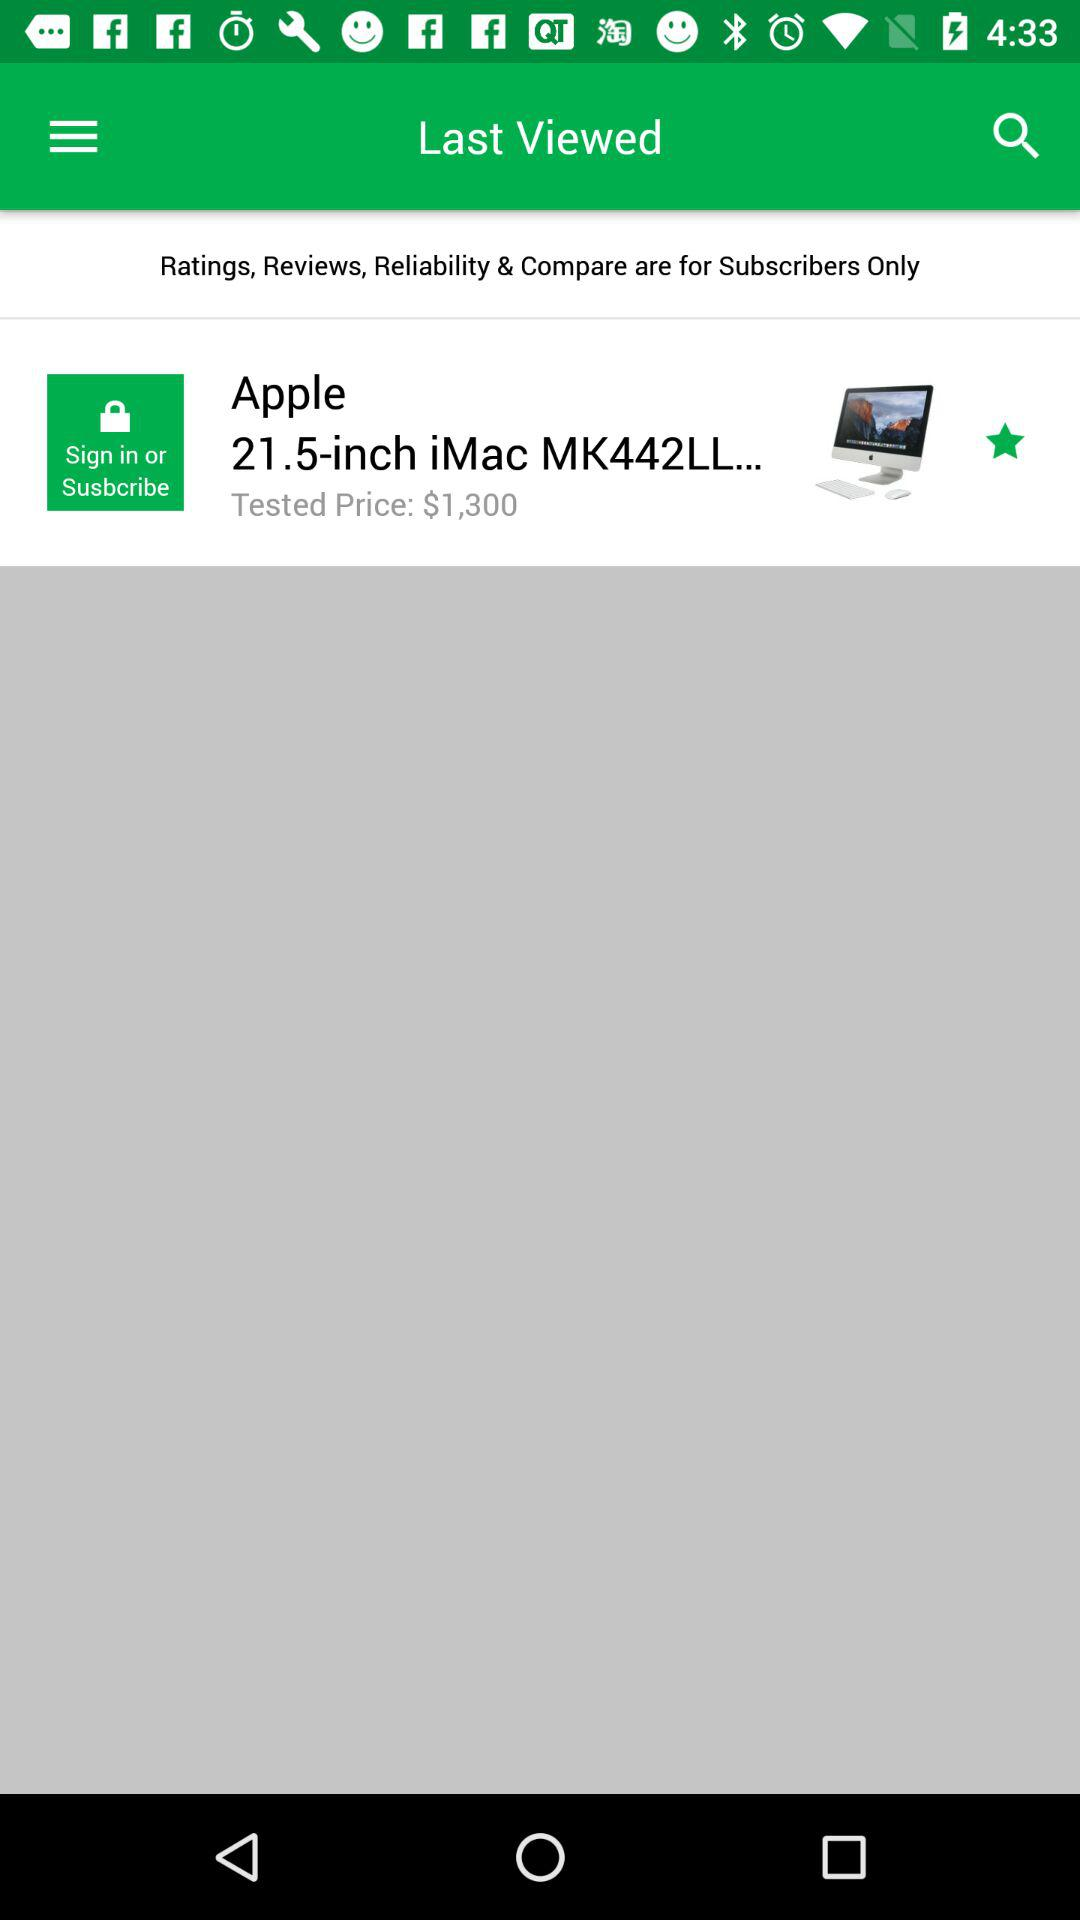What is the name of the product? The name of the product is "Apple 21.5-inch iMac MK442LL...". 